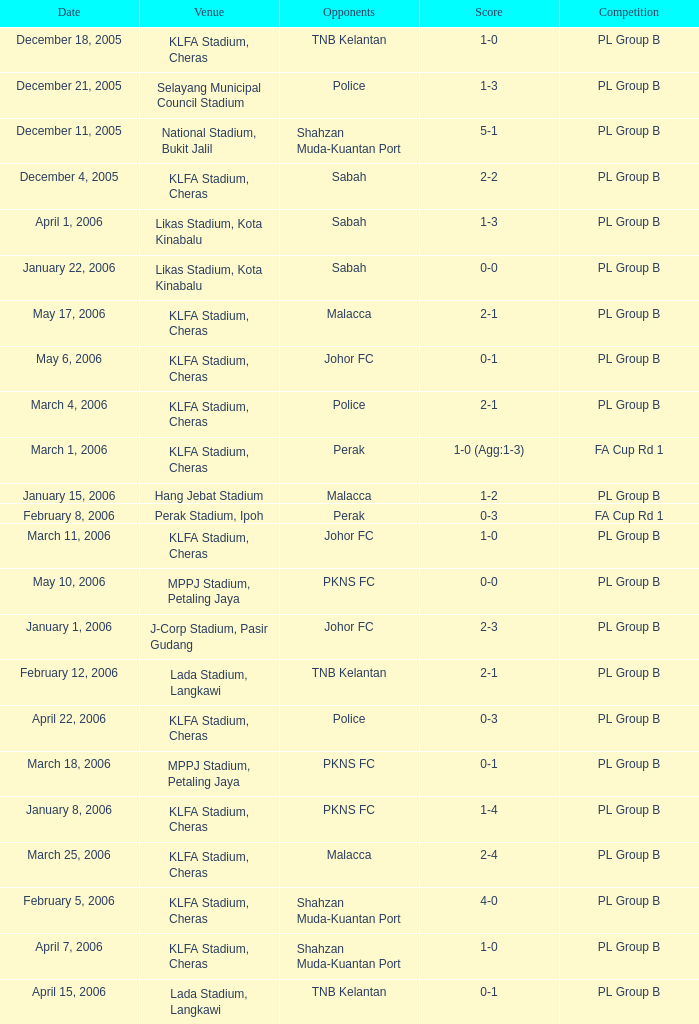Who were the competitors on may 6th, 2006? Johor FC. 